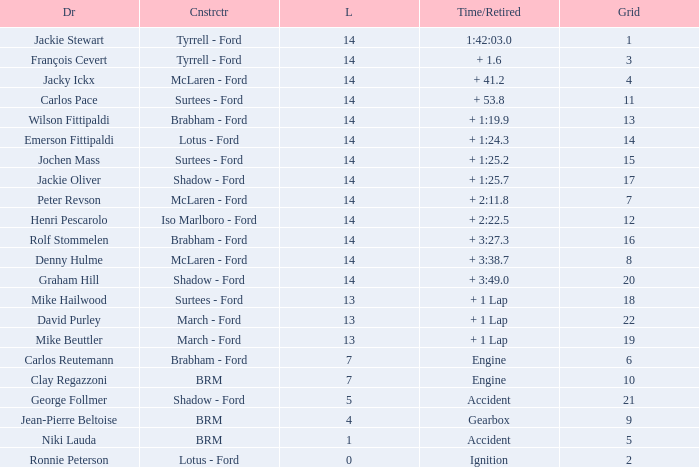What is the low lap total for a grid larger than 16 and has a Time/Retired of + 3:27.3? None. 